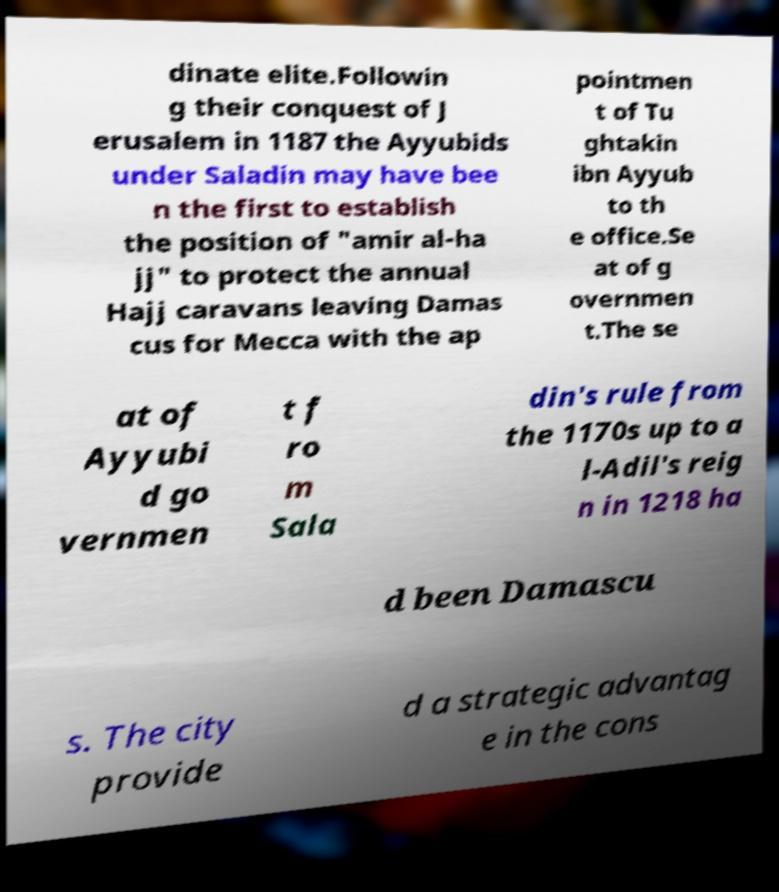Please identify and transcribe the text found in this image. dinate elite.Followin g their conquest of J erusalem in 1187 the Ayyubids under Saladin may have bee n the first to establish the position of "amir al-ha jj" to protect the annual Hajj caravans leaving Damas cus for Mecca with the ap pointmen t of Tu ghtakin ibn Ayyub to th e office.Se at of g overnmen t.The se at of Ayyubi d go vernmen t f ro m Sala din's rule from the 1170s up to a l-Adil's reig n in 1218 ha d been Damascu s. The city provide d a strategic advantag e in the cons 